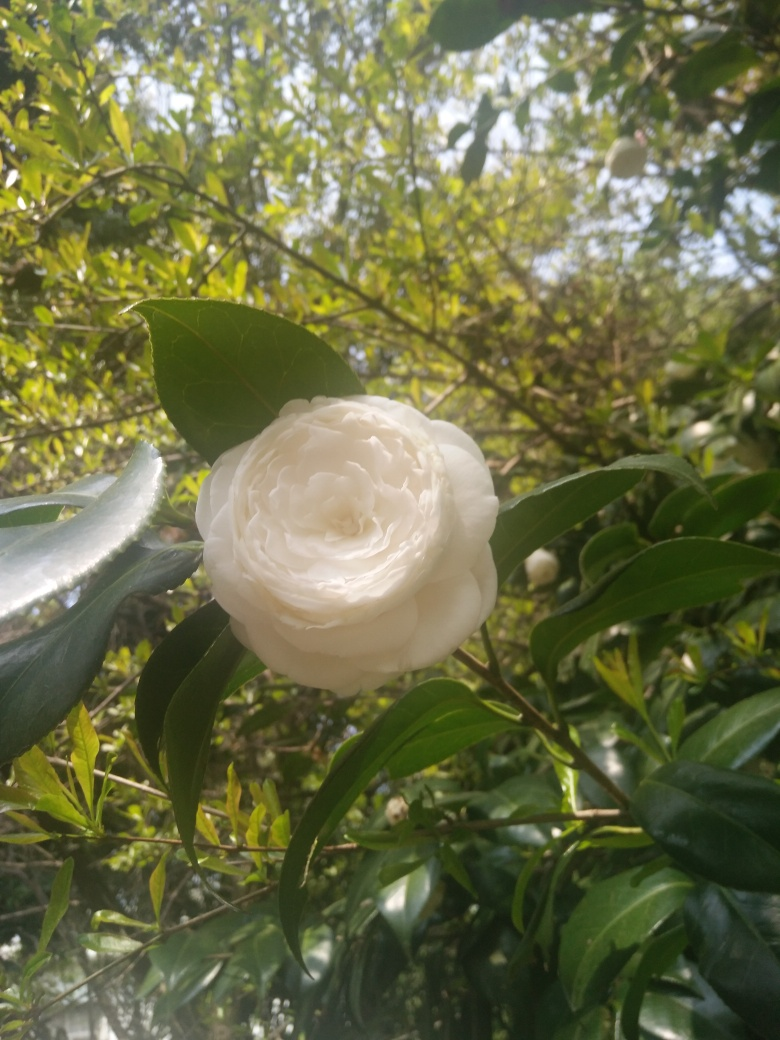What can you infer about the environment where this flower is growing? The surrounding foliage suggests that the flower is growing in a well-cared-for garden or park with rich greenery. There appears to be a variety of other plants in the vicinity, which indicates a diverse and healthy ecosystem. Do you think this flower has significance? The camellia flower often holds various meanings ranging from love and adoration to admiration for someone's inner beauty. Depending on the context, such as in different cultures or settings, it can have additional significance. 